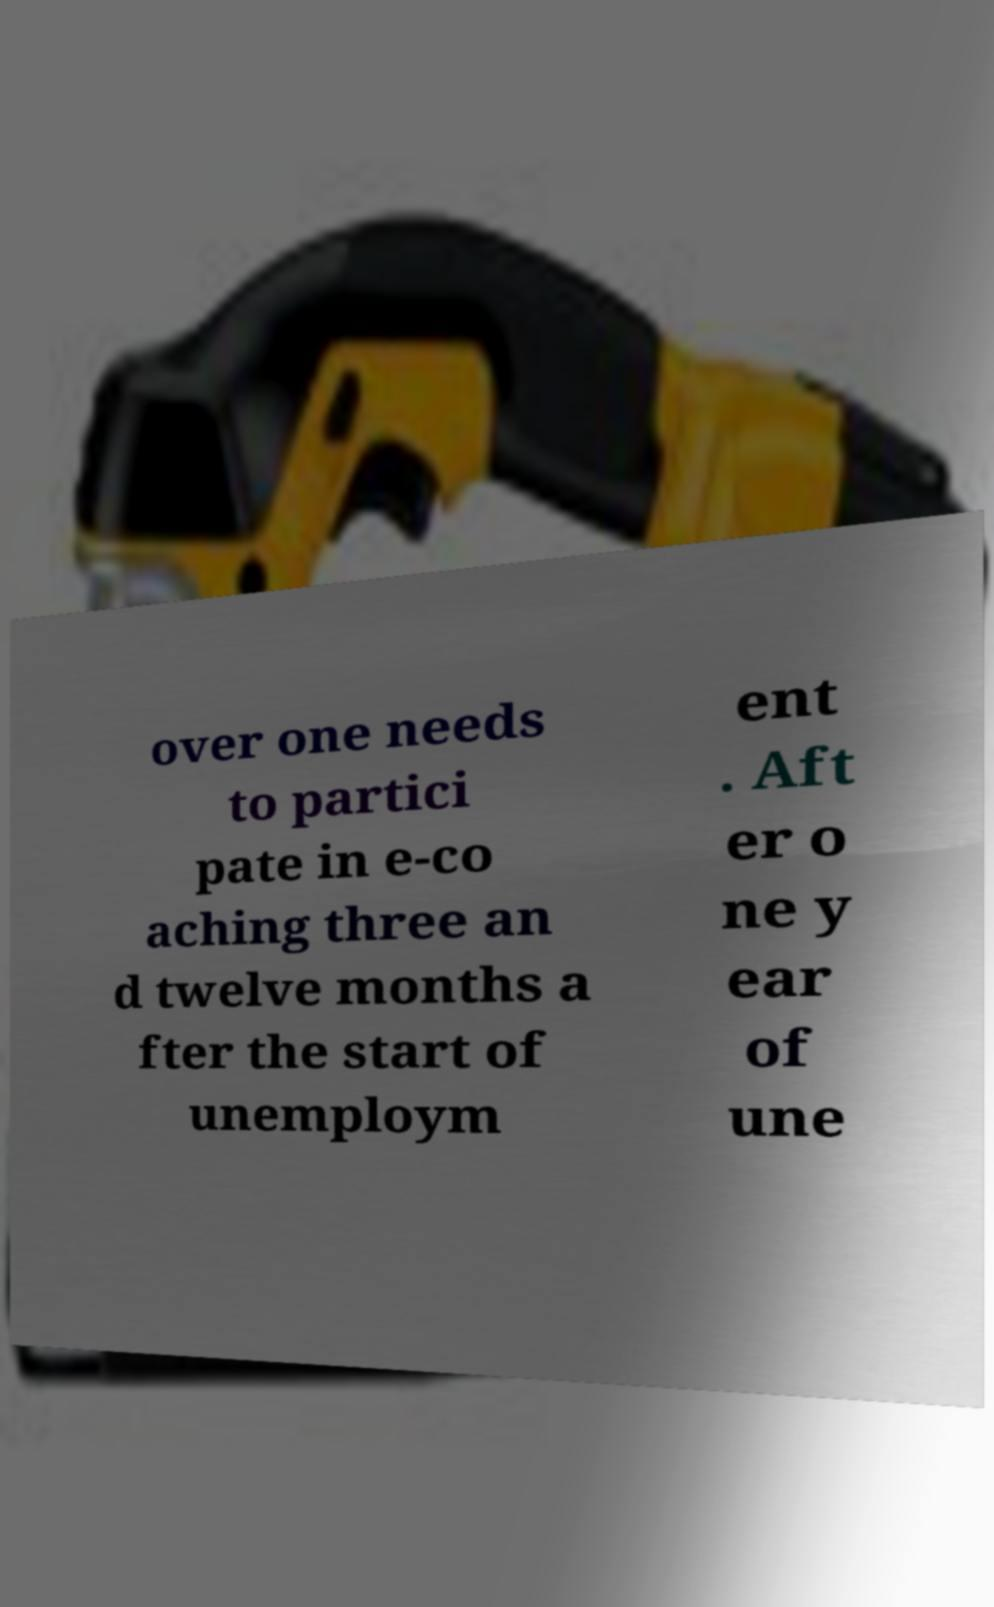Please read and relay the text visible in this image. What does it say? over one needs to partici pate in e-co aching three an d twelve months a fter the start of unemploym ent . Aft er o ne y ear of une 